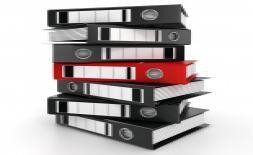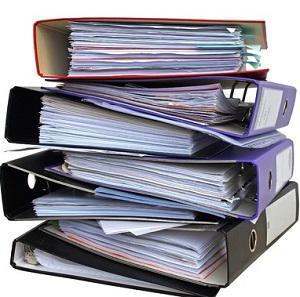The first image is the image on the left, the second image is the image on the right. For the images displayed, is the sentence "At least one image shows binders stacked alternately front-to-back, with no more than seven total binders in the image." factually correct? Answer yes or no. Yes. 